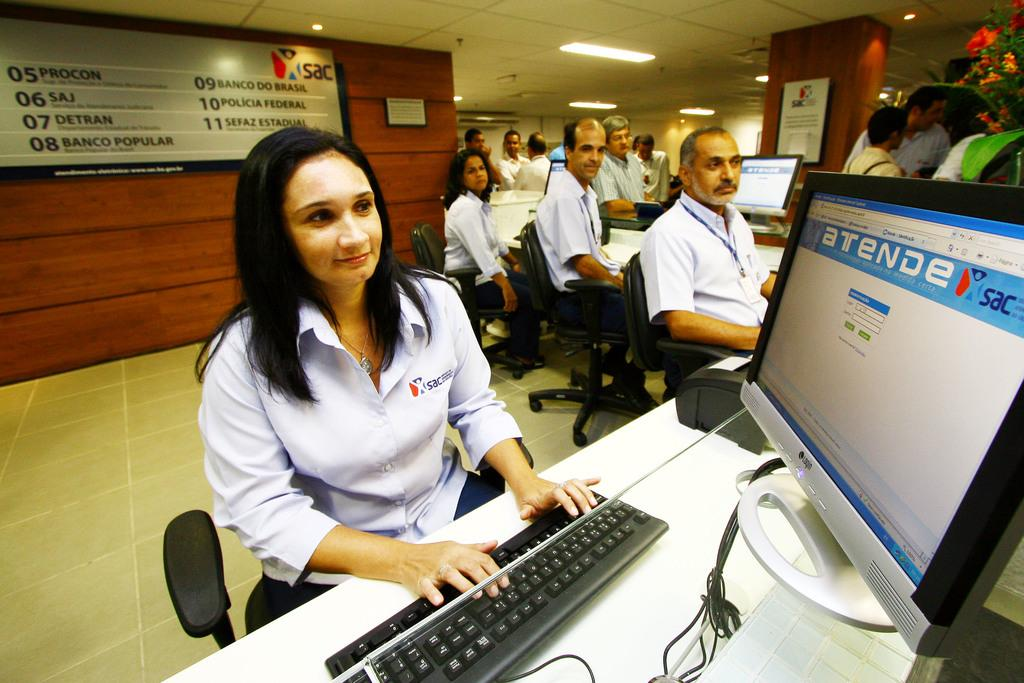<image>
Give a short and clear explanation of the subsequent image. A women types as she views a monitor that displays an atende page. 